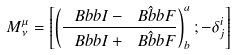<formula> <loc_0><loc_0><loc_500><loc_500>M _ { \nu } ^ { \mu } = \left [ \left ( \frac { { \ B b b I } - \hat { \ B b b F } } { { \ B b b I } + \hat { \ B b b F } } \right ) _ { b } ^ { a } ; - \delta _ { j } ^ { i } \right ]</formula> 